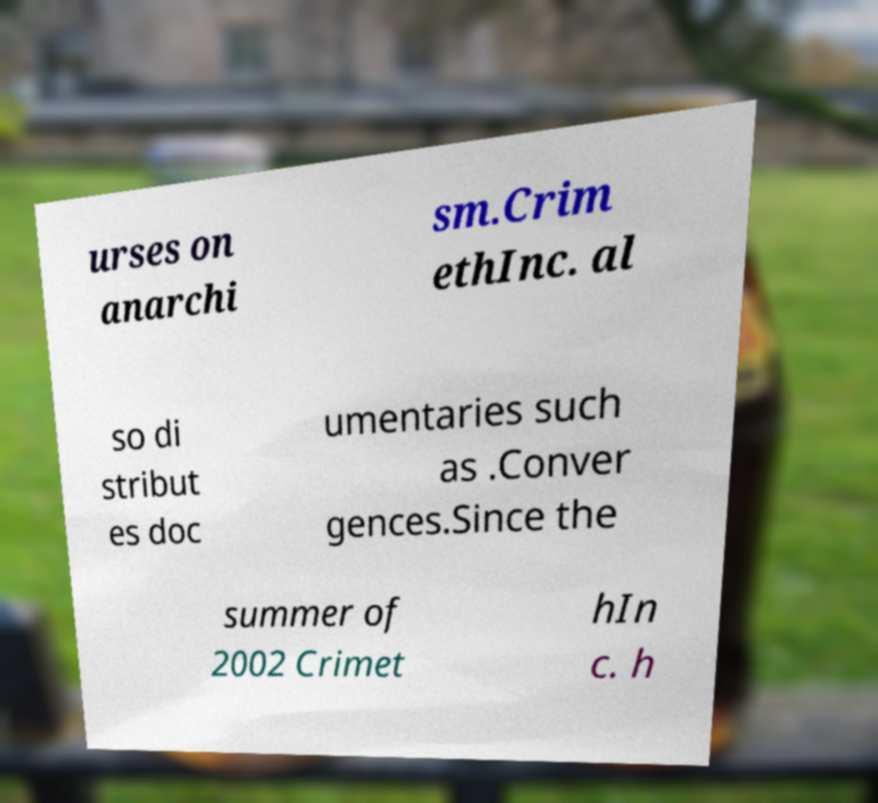I need the written content from this picture converted into text. Can you do that? urses on anarchi sm.Crim ethInc. al so di stribut es doc umentaries such as .Conver gences.Since the summer of 2002 Crimet hIn c. h 